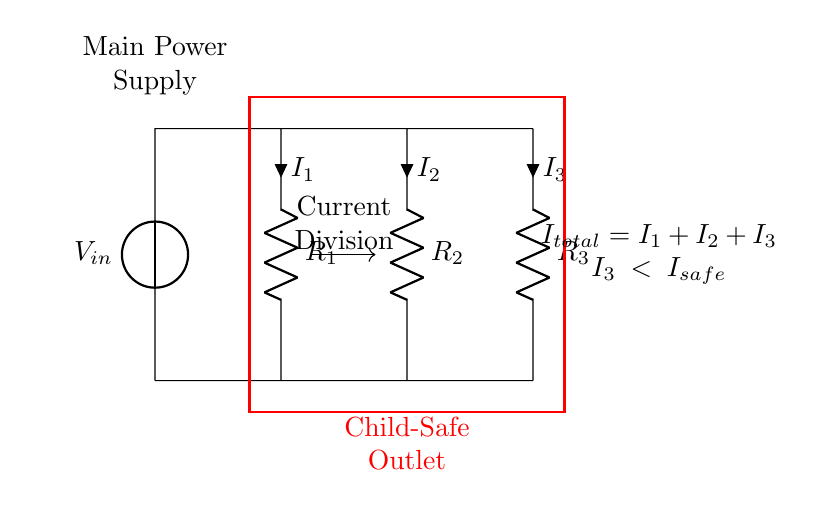What are the components in the circuit? The circuit includes a voltage source and three resistors. This is identified visually from the circuit diagram, where each element is labeled accordingly.
Answer: voltage source, three resistors What does the rectangle represent in the diagram? The red rectangle symbolizes the child-safe outlet, indicating an area designed to prevent accidental electric shocks. This can be inferred from the label inside the rectangle.
Answer: Child-Safe Outlet What is the total current in the circuit? The total current can be represented as the sum of the individual currents through the three resistors. It is indicated in the diagram as I total equals I 1 plus I 2 plus I 3.
Answer: I total = I 1 + I 2 + I 3 What is the condition for I 3? The diagram specifies that I 3 must be less than the safe current level, denoted as I safe, ensuring that the current through the third resistor does not pose a hazard. This is indicated in the note below the circuit.
Answer: I 3 < I safe How does current division occur in this circuit? Current division occurs by distributing the total current among the resistors in proportion to their resistances. This is a fundamental property of parallel circuits, as shown by the current direction arrows and their labels.
Answer: By resistance values Why is current division important for childproofing outlets? Current division is crucial because it ensures that the amount of current flowing through any path (especially into the outlet) is kept below safe levels. This prevents electric shocks, especially in devices used by children. The diagram explicitly portrays this mechanism and allows for current management.
Answer: Prevents electric shocks 